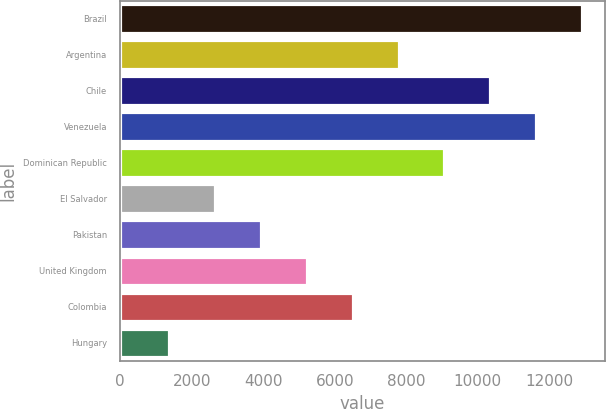<chart> <loc_0><loc_0><loc_500><loc_500><bar_chart><fcel>Brazil<fcel>Argentina<fcel>Chile<fcel>Venezuela<fcel>Dominican Republic<fcel>El Salvador<fcel>Pakistan<fcel>United Kingdom<fcel>Colombia<fcel>Hungary<nl><fcel>12915<fcel>7785.4<fcel>10350.2<fcel>11632.6<fcel>9067.8<fcel>2655.8<fcel>3938.2<fcel>5220.6<fcel>6503<fcel>1373.4<nl></chart> 